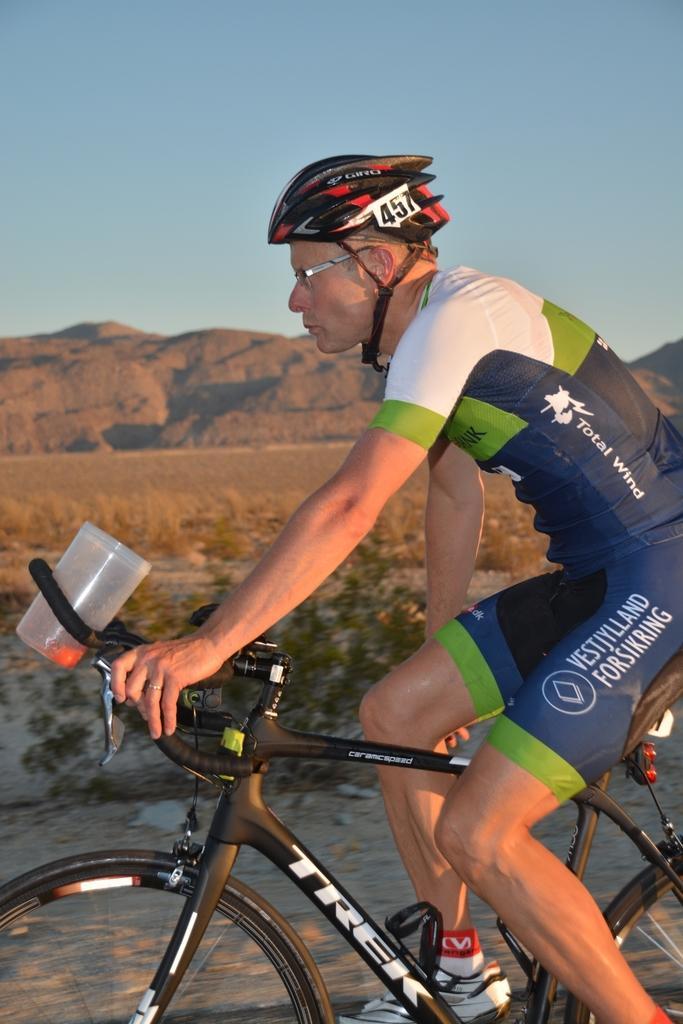Please provide a concise description of this image. In the center of the image there is a person riding a bicycle. He is wearing a helmet. In the background of the image there are mountains. There is dry grass. 